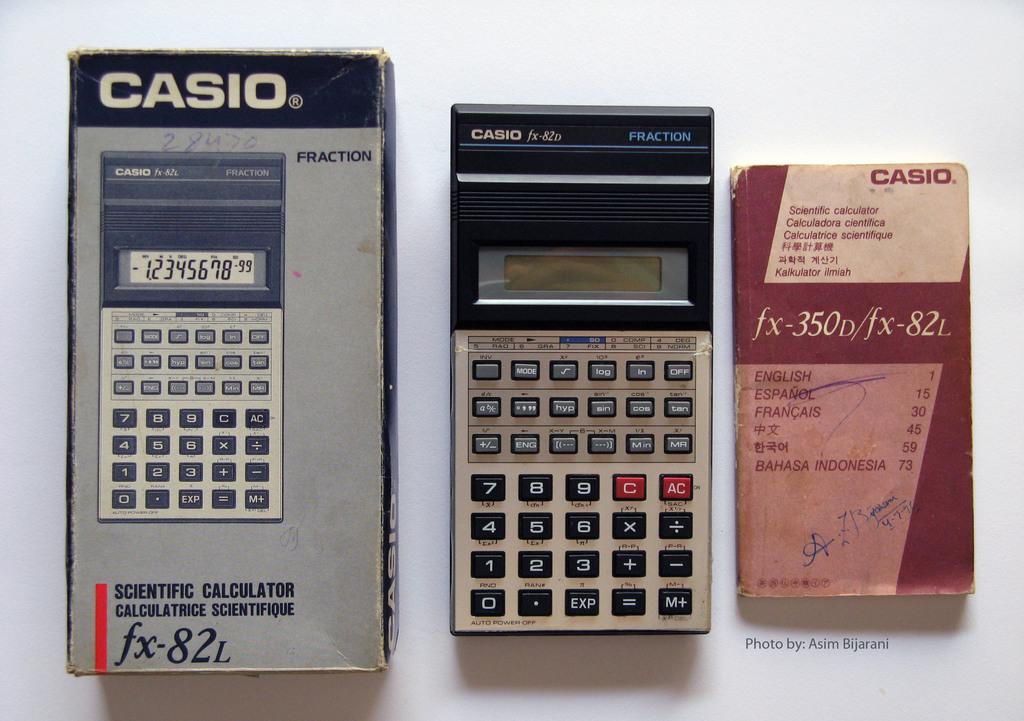What brand calculator is this?
Offer a very short reply. Casio. What type of casio calculator is this?
Your answer should be very brief. Scientific. 